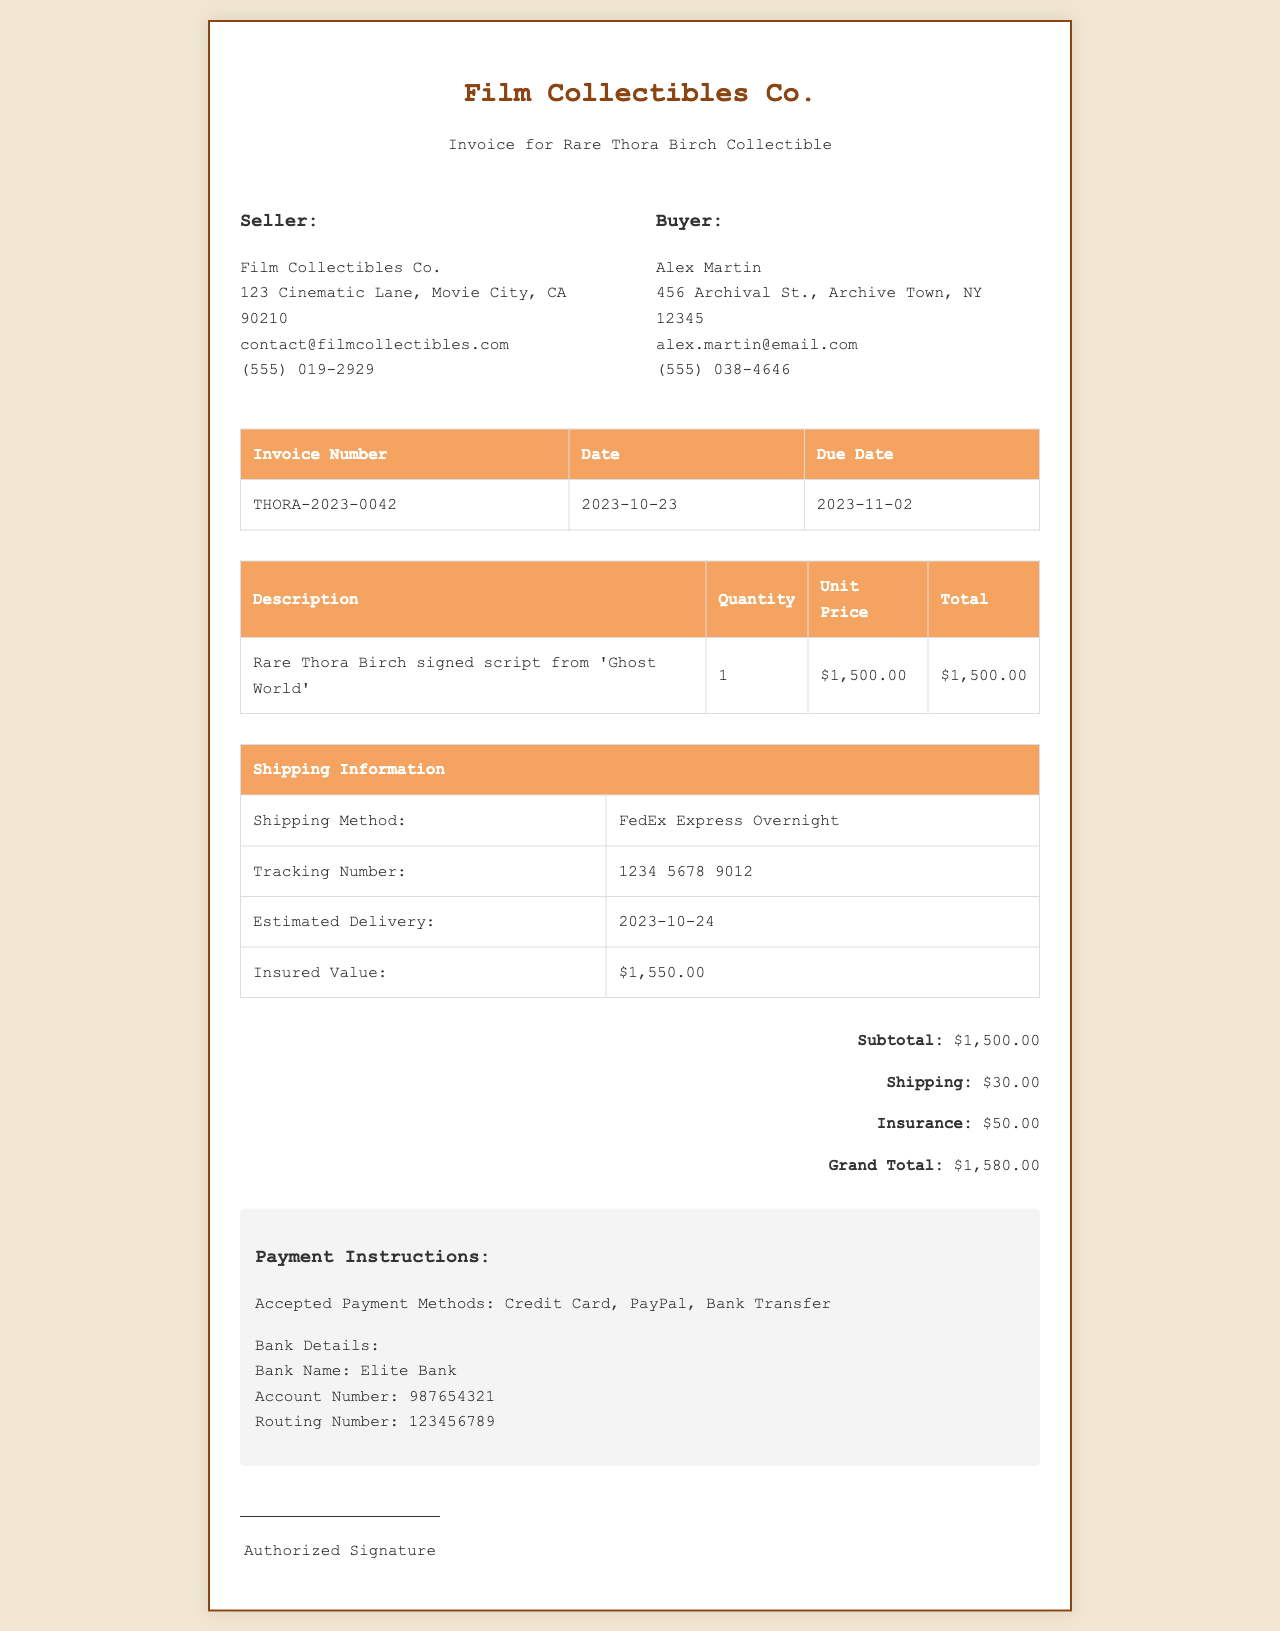what is the invoice number? The invoice number is listed in the document as THORA-2023-0042.
Answer: THORA-2023-0042 what is the seller's contact email? The seller's contact email is provided in the document as contact@filmcollectibles.com.
Answer: contact@filmcollectibles.com what is the total amount due? The total amount due is calculated from the subtotal, shipping, and insurance, which sums to $1,580.00.
Answer: $1,580.00 what is the shipping method used? The shipping method is indicated in the document as FedEx Express Overnight.
Answer: FedEx Express Overnight what is the insured value of the collectible? The insured value is specified in the shipping information section of the document as $1,550.00.
Answer: $1,550.00 what date is the invoice due? The due date for the invoice is stated in the document as 2023-11-02.
Answer: 2023-11-02 how much is the shipping cost? The shipping cost is detailed in the total section of the document as $30.00.
Answer: $30.00 who is the buyer? The buyer's name is listed in the document as Alex Martin.
Answer: Alex Martin what is the tracking number for the shipment? The tracking number can be found under the shipping information and is noted as 1234 5678 9012.
Answer: 1234 5678 9012 